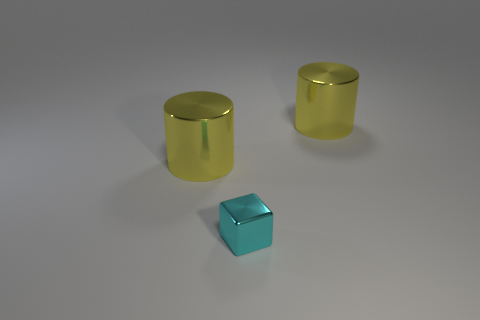Subtract all green cubes. Subtract all blue cylinders. How many cubes are left? 1 Add 1 blue rubber cylinders. How many objects exist? 4 Subtract all blocks. How many objects are left? 2 Subtract 0 blue cylinders. How many objects are left? 3 Subtract all large yellow shiny objects. Subtract all small things. How many objects are left? 0 Add 2 cyan things. How many cyan things are left? 3 Add 3 tiny purple metallic things. How many tiny purple metallic things exist? 3 